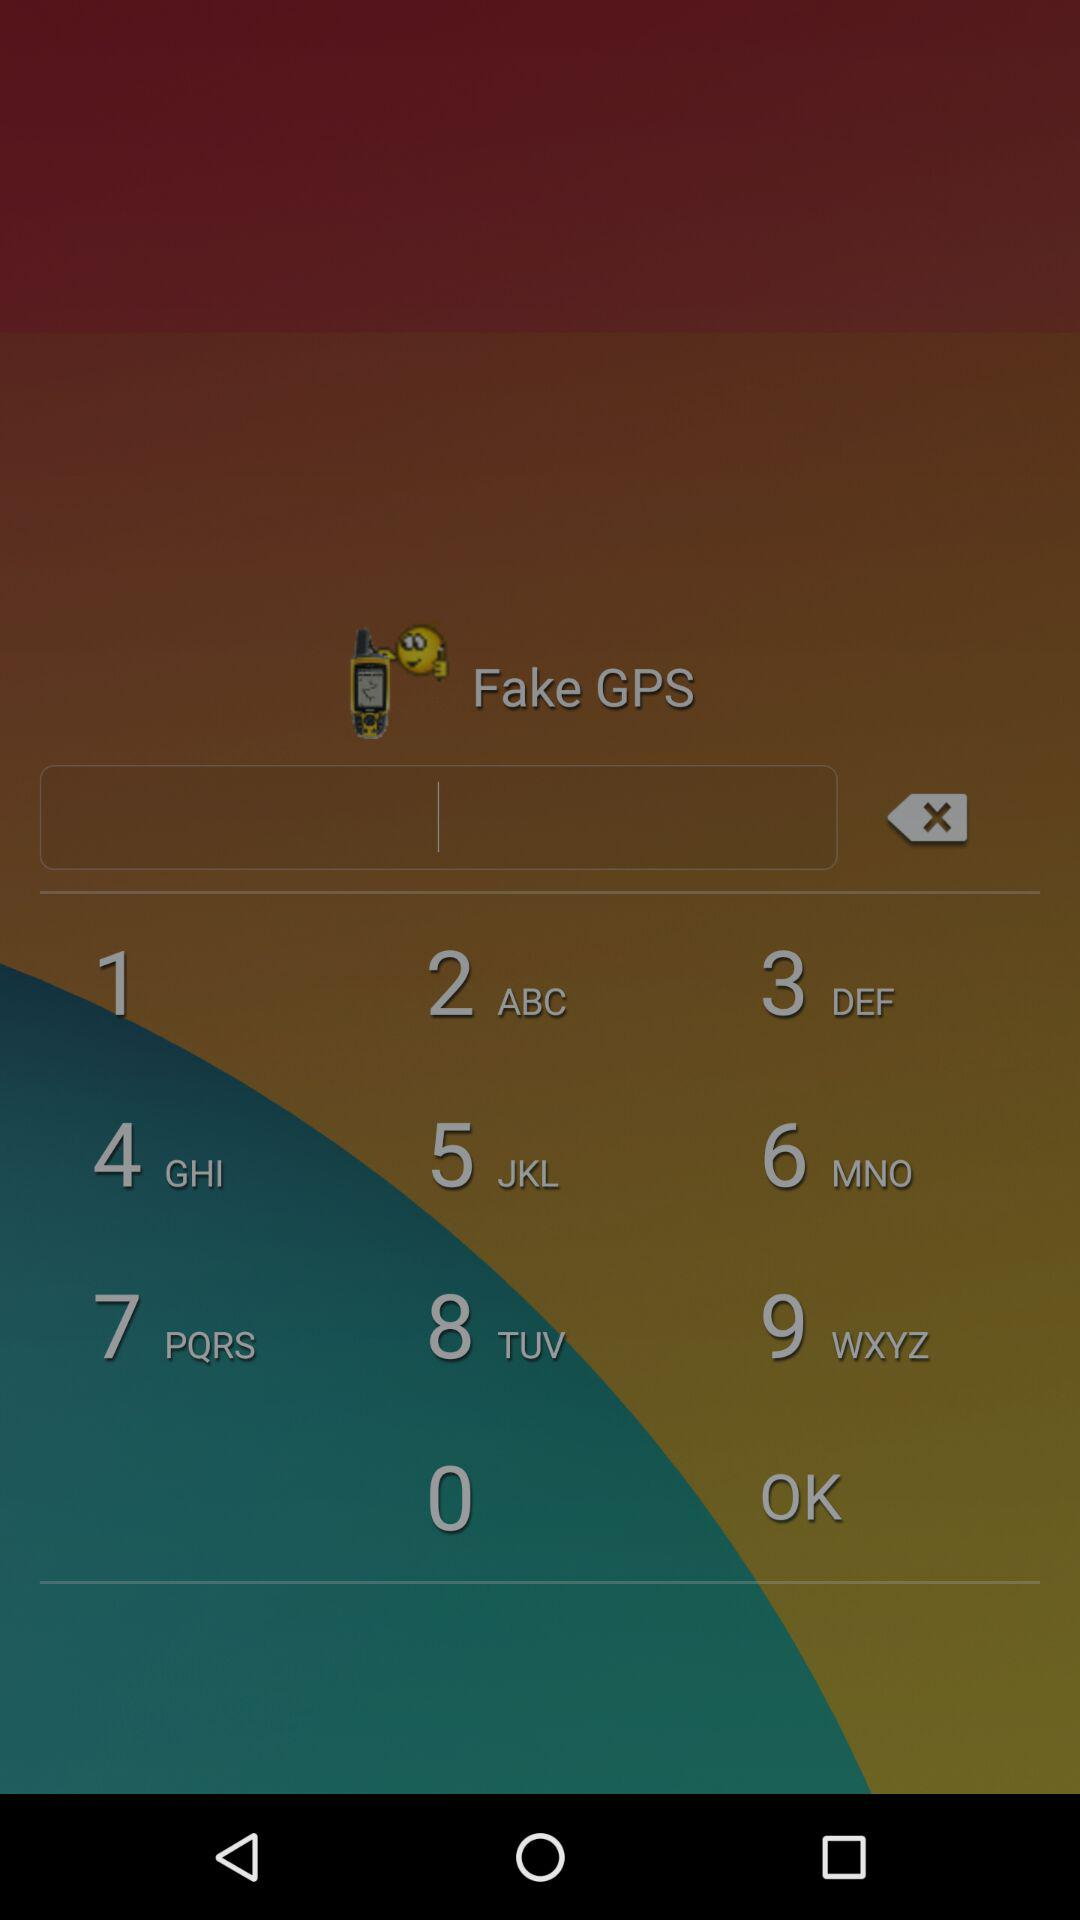What is the address of Sam? The address of Sam is 959 Ridge Avenue, United States, HI 60007. 